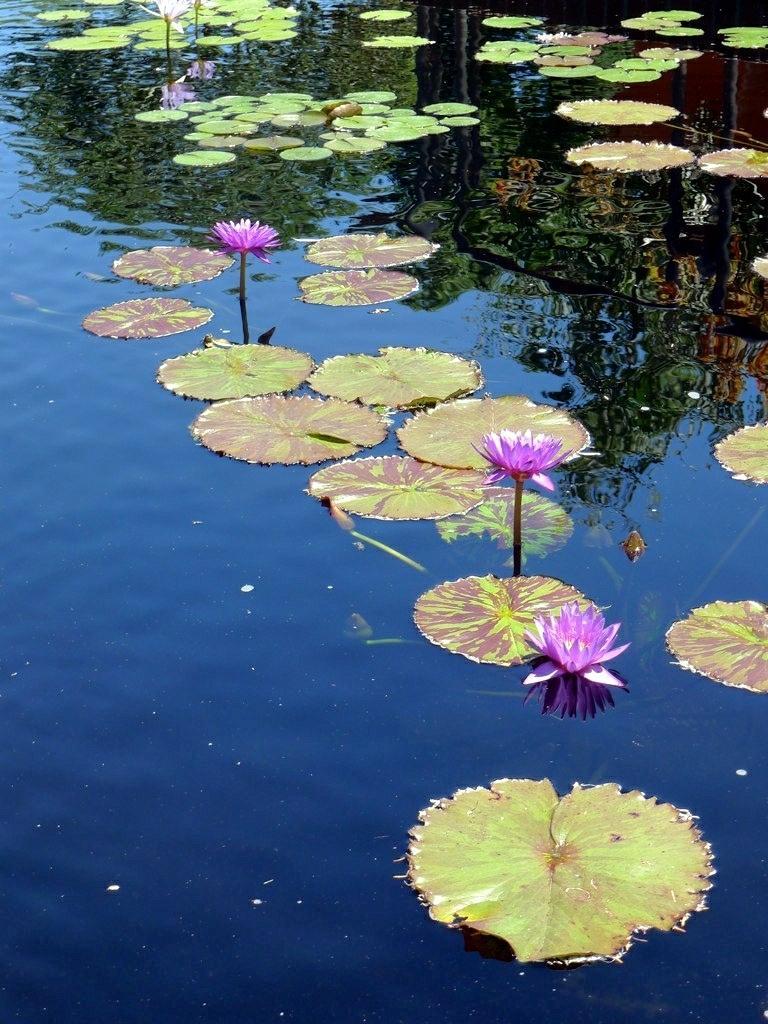Could you give a brief overview of what you see in this image? In this image I can see few pink color lotus flowers and few lotus leaves on the water. 